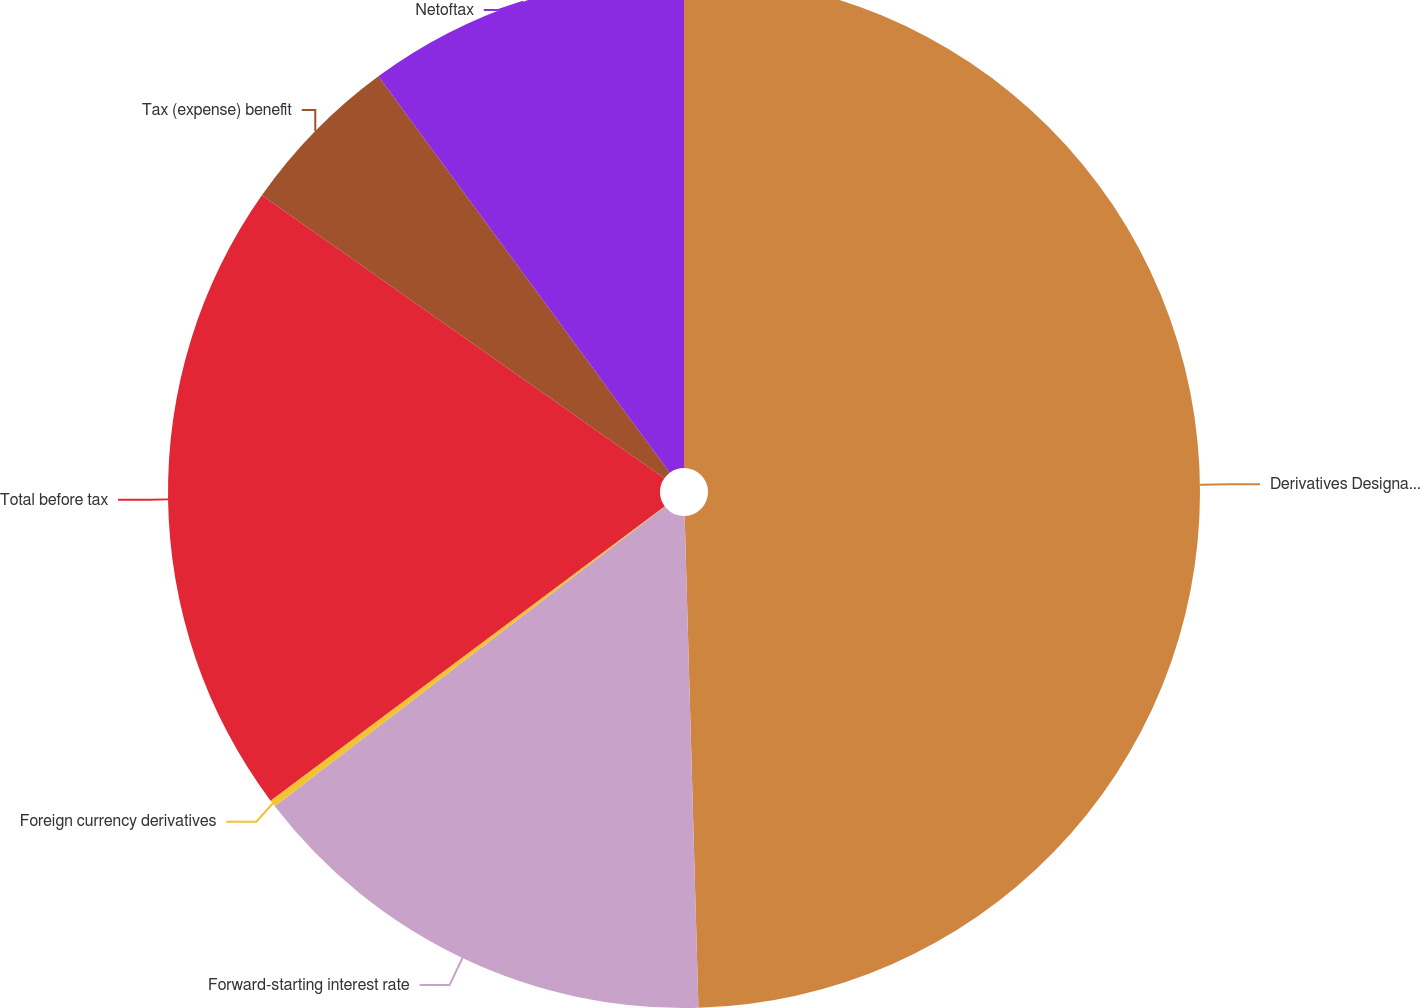<chart> <loc_0><loc_0><loc_500><loc_500><pie_chart><fcel>Derivatives Designated as Cash<fcel>Forward-starting interest rate<fcel>Foreign currency derivatives<fcel>Total before tax<fcel>Tax (expense) benefit<fcel>Netoftax<nl><fcel>49.56%<fcel>15.02%<fcel>0.22%<fcel>19.96%<fcel>5.16%<fcel>10.09%<nl></chart> 